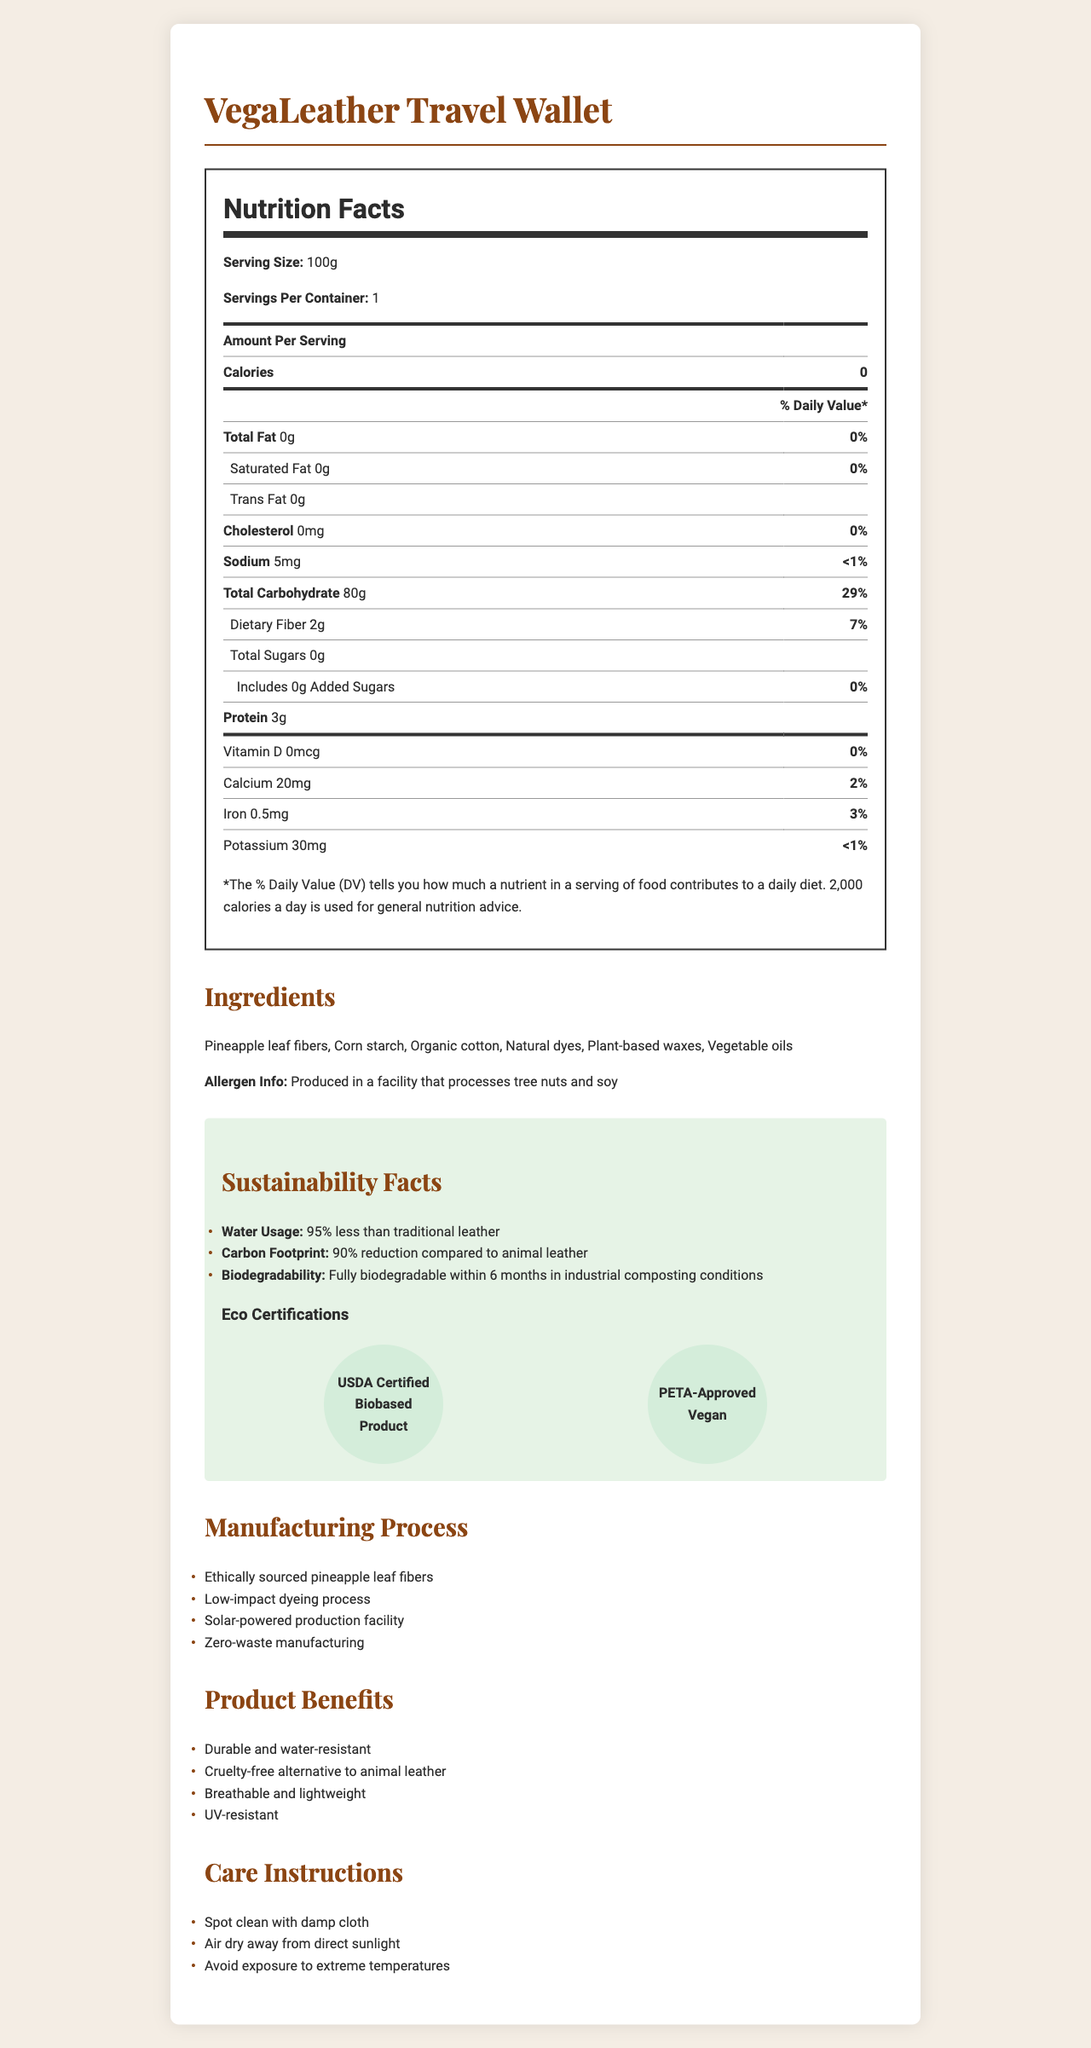What is the serving size of the VegaLeather Travel Wallet? The serving size is clearly indicated in the Nutrition Facts section as "Serving Size: 100g."
Answer: 100g How much sodium is in a serving? The amount of sodium per serving is listed as "5mg" in the Nutrition Facts section.
Answer: 5mg What is the percent daily value of total carbohydrates? The percent daily value of total carbohydrates is listed as "29%" in the Nutrition Facts section.
Answer: 29% List two ingredients used in the VegaLeather Travel Wallet. Pineapple leaf fibers and corn starch are two of the ingredients listed in the ingredients section.
Answer: Pineapple leaf fibers, Corn starch What are the manufacturing processes mentioned in the document? All of these manufacturing processes are listed under the Manufacturing Process section of the document.
Answer: Ethically sourced pineapple leaf fibers, Low-impact dyeing process, Solar-powered production facility, Zero-waste manufacturing What is the protein content per serving? The protein content per serving is listed as "3g" in the Nutrition Facts section.
Answer: 3g Which of the following certifications does the product have? A. Fair Trade Certified B. USDA Certified Biobased Product C. FSC Certified The document lists "USDA Certified Biobased Product" under Eco Certifications.
Answer: B. USDA Certified Biobased Product What is the total fat content of the product? A. 0g B. 5g C. 10g The total fat content is listed as "0g" in the Nutrition Facts section.
Answer: A. 0g Is the product cruelty-free? The document mentions that the product is cruelty-free as one of the product benefits.
Answer: Yes Summarize the key environmental benefits of the VegaLeather Travel Wallet. The document highlights the environmental sustainability of the VegaLeather Travel Wallet, detailing its reduced water usage and carbon footprint, biodegradability, and eco-certifications, along with ethical and low-impact manufacturing processes.
Answer: The VegaLeather Travel Wallet is highly sustainable, using 95% less water and 90% less carbon footprint compared to traditional leather and is fully biodegradable within 6 months in industrial composting conditions. It holds eco-certifications like USDA Certified Biobased Product and PETA-Approved Vegan, and its manufacturing processes are ethical, low-impact, and zero-waste. Is the product high in total carbohydrates? The product contains 80g of total carbohydrates per serving, which constitutes 29% of the daily value, indicating it is relatively high in carbohydrates.
Answer: Yes What are the care instructions for the VegaLeather Travel Wallet? These care instructions are listed at the end of the document under Care Instructions.
Answer: Spot clean with damp cloth, Air dry away from direct sunlight, Avoid exposure to extreme temperatures Where is the information about whether the product is organic? The document does not provide specific information about whether the product is fully organic, apart from mentioning "organic cotton" as an ingredient.
Answer: Cannot be determined 